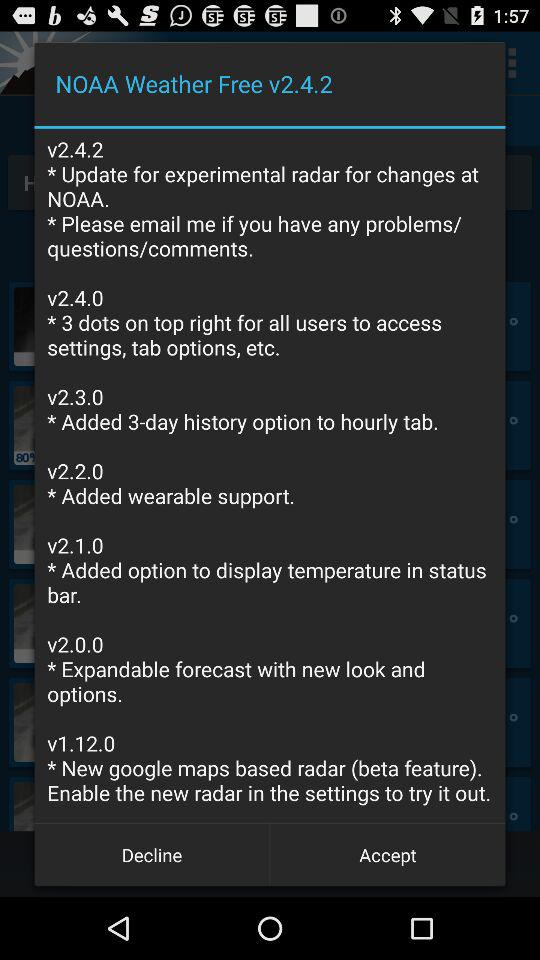What changes were made in version v2.2.0? The change made in version v2.2.0 was "Added wearable support". 